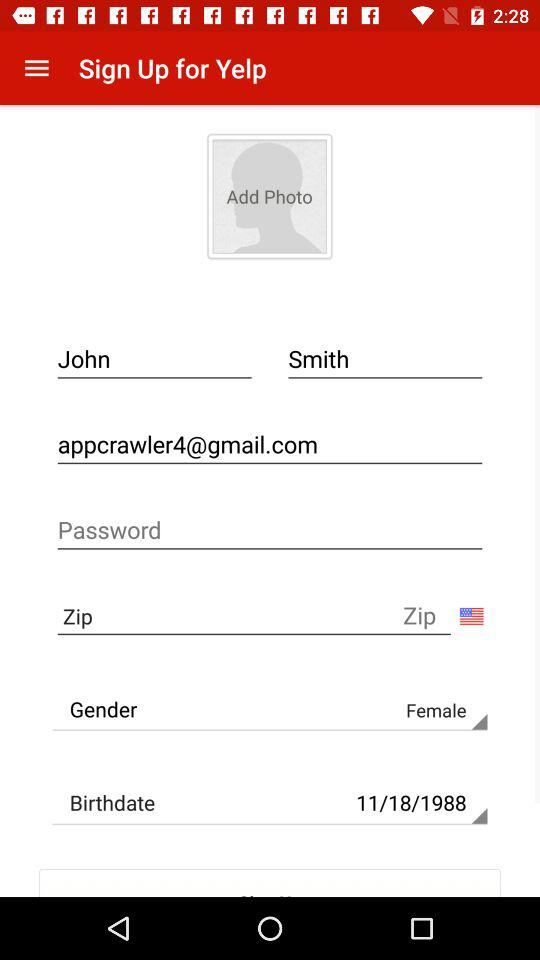What's the gender? The gender is "Female". 